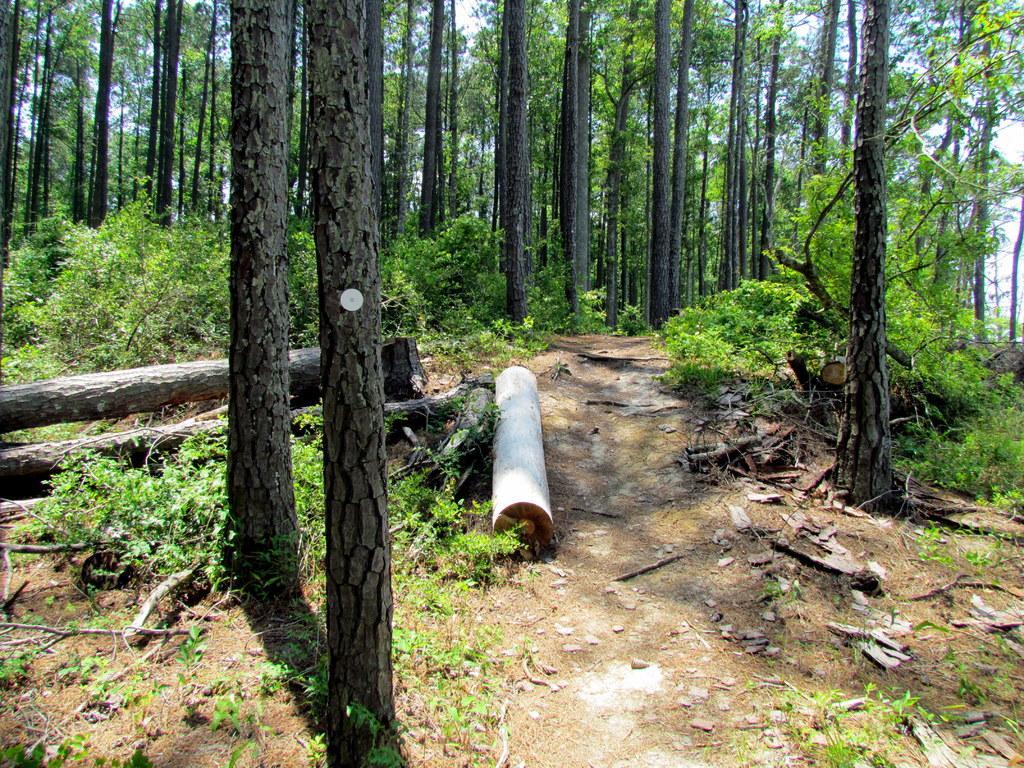Can you describe this image briefly? In this image there are trees, branches and plants. Through trees sky is visible.  